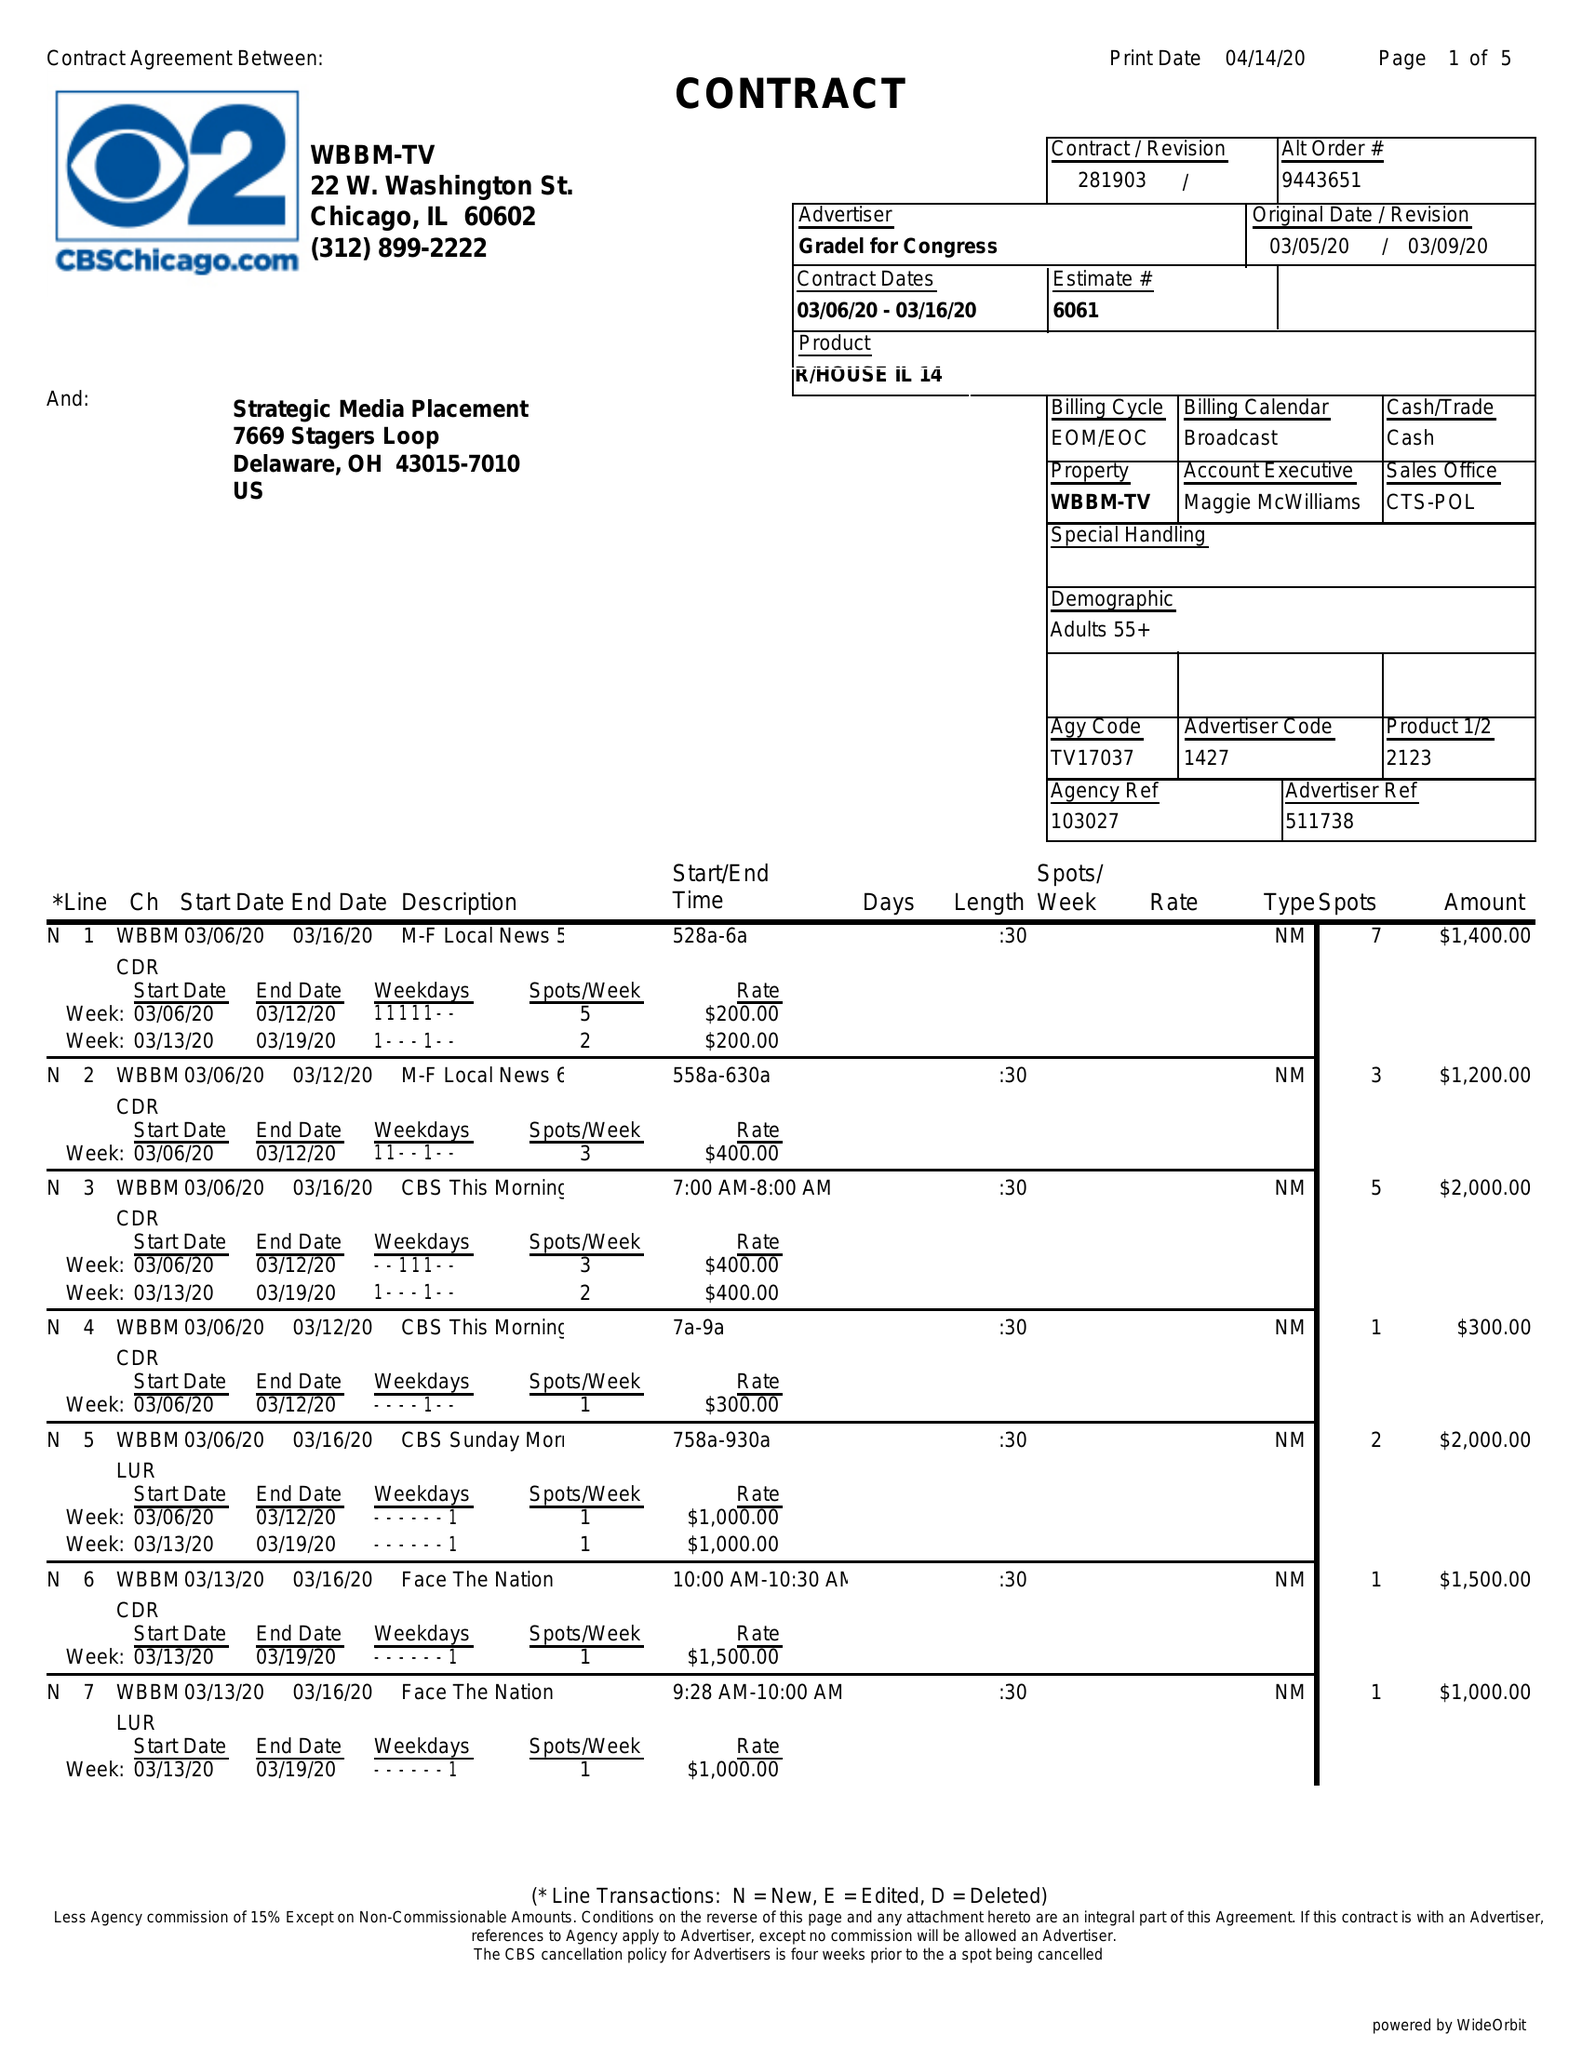What is the value for the advertiser?
Answer the question using a single word or phrase. GRADEL FOR CONGRESS 